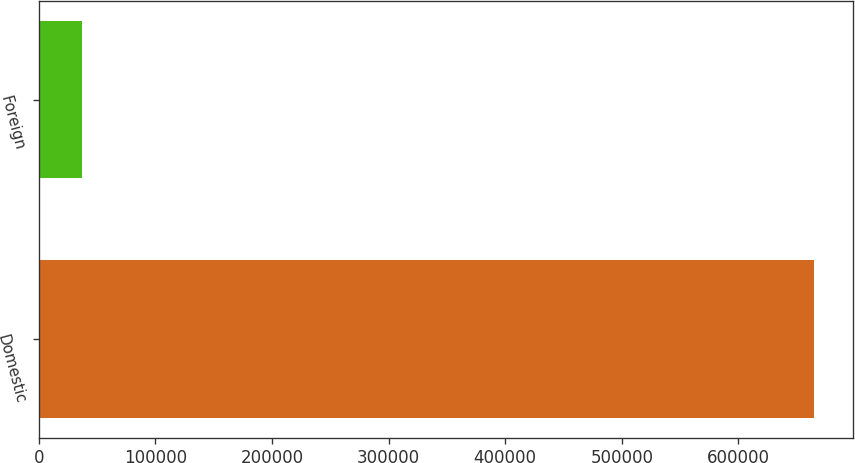Convert chart. <chart><loc_0><loc_0><loc_500><loc_500><bar_chart><fcel>Domestic<fcel>Foreign<nl><fcel>664966<fcel>37045<nl></chart> 